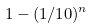<formula> <loc_0><loc_0><loc_500><loc_500>1 - ( 1 / 1 0 ) ^ { n }</formula> 